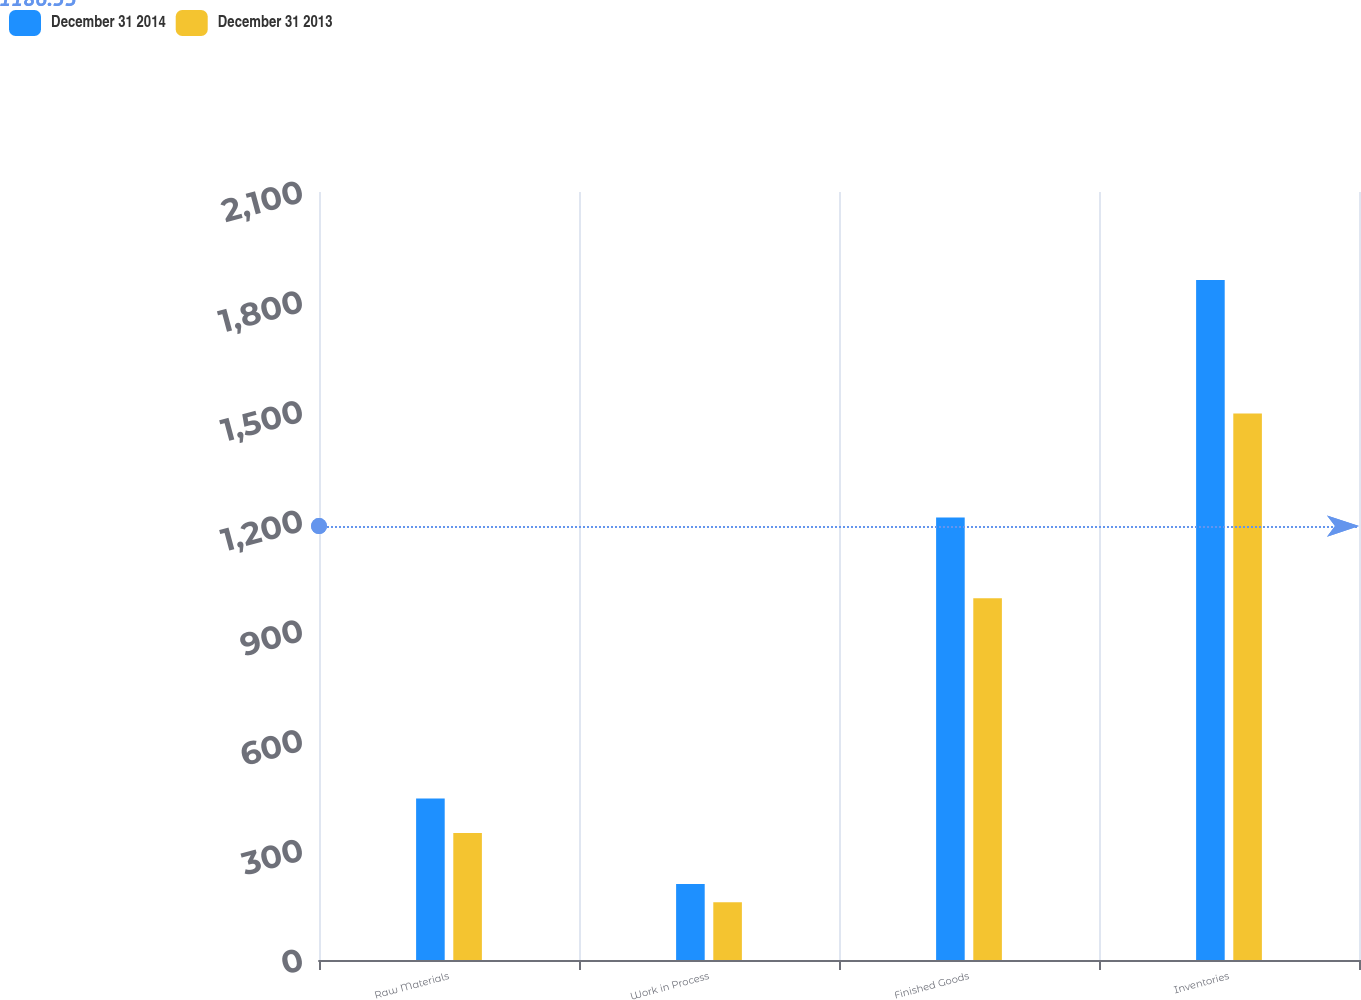<chart> <loc_0><loc_0><loc_500><loc_500><stacked_bar_chart><ecel><fcel>Raw Materials<fcel>Work in Process<fcel>Finished Goods<fcel>Inventories<nl><fcel>December 31 2014<fcel>441.6<fcel>207.6<fcel>1210.3<fcel>1859.5<nl><fcel>December 31 2013<fcel>347.4<fcel>157.7<fcel>989.4<fcel>1494.5<nl></chart> 